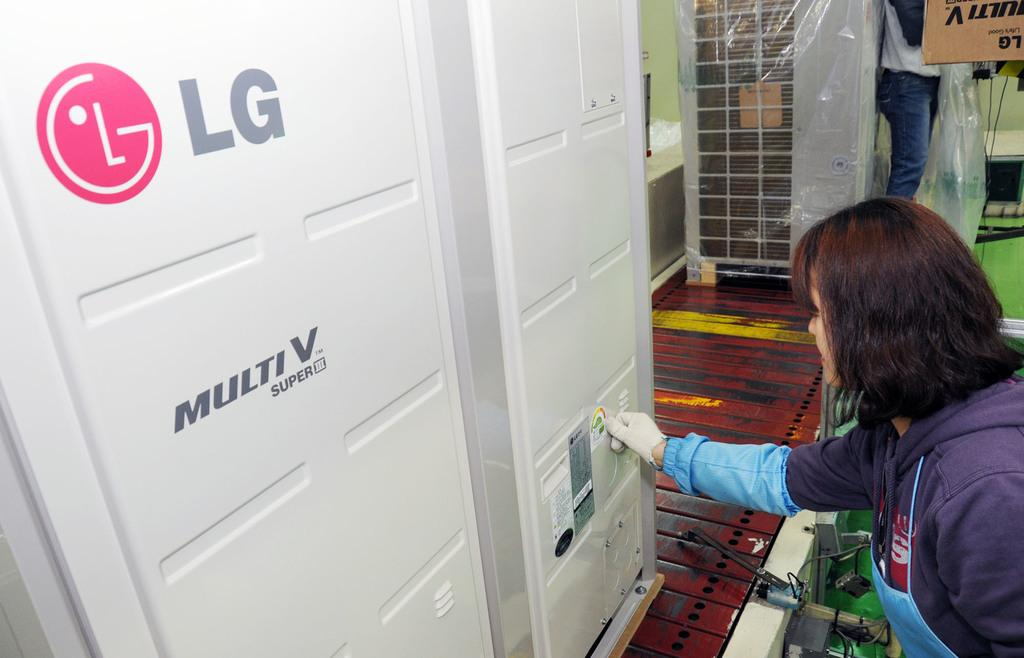<image>
Provide a brief description of the given image. a lady standing next to an LG door 